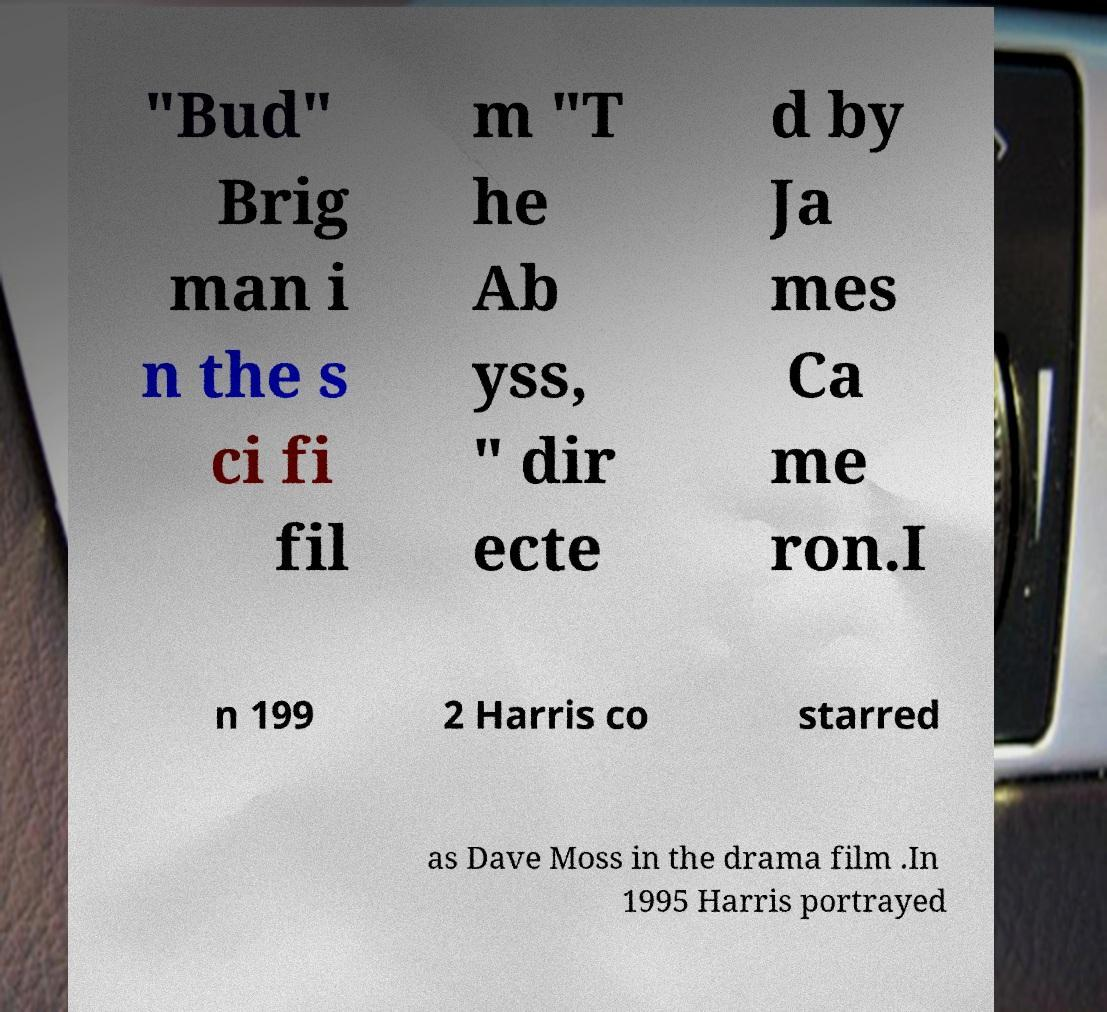Please identify and transcribe the text found in this image. "Bud" Brig man i n the s ci fi fil m "T he Ab yss, " dir ecte d by Ja mes Ca me ron.I n 199 2 Harris co starred as Dave Moss in the drama film .In 1995 Harris portrayed 